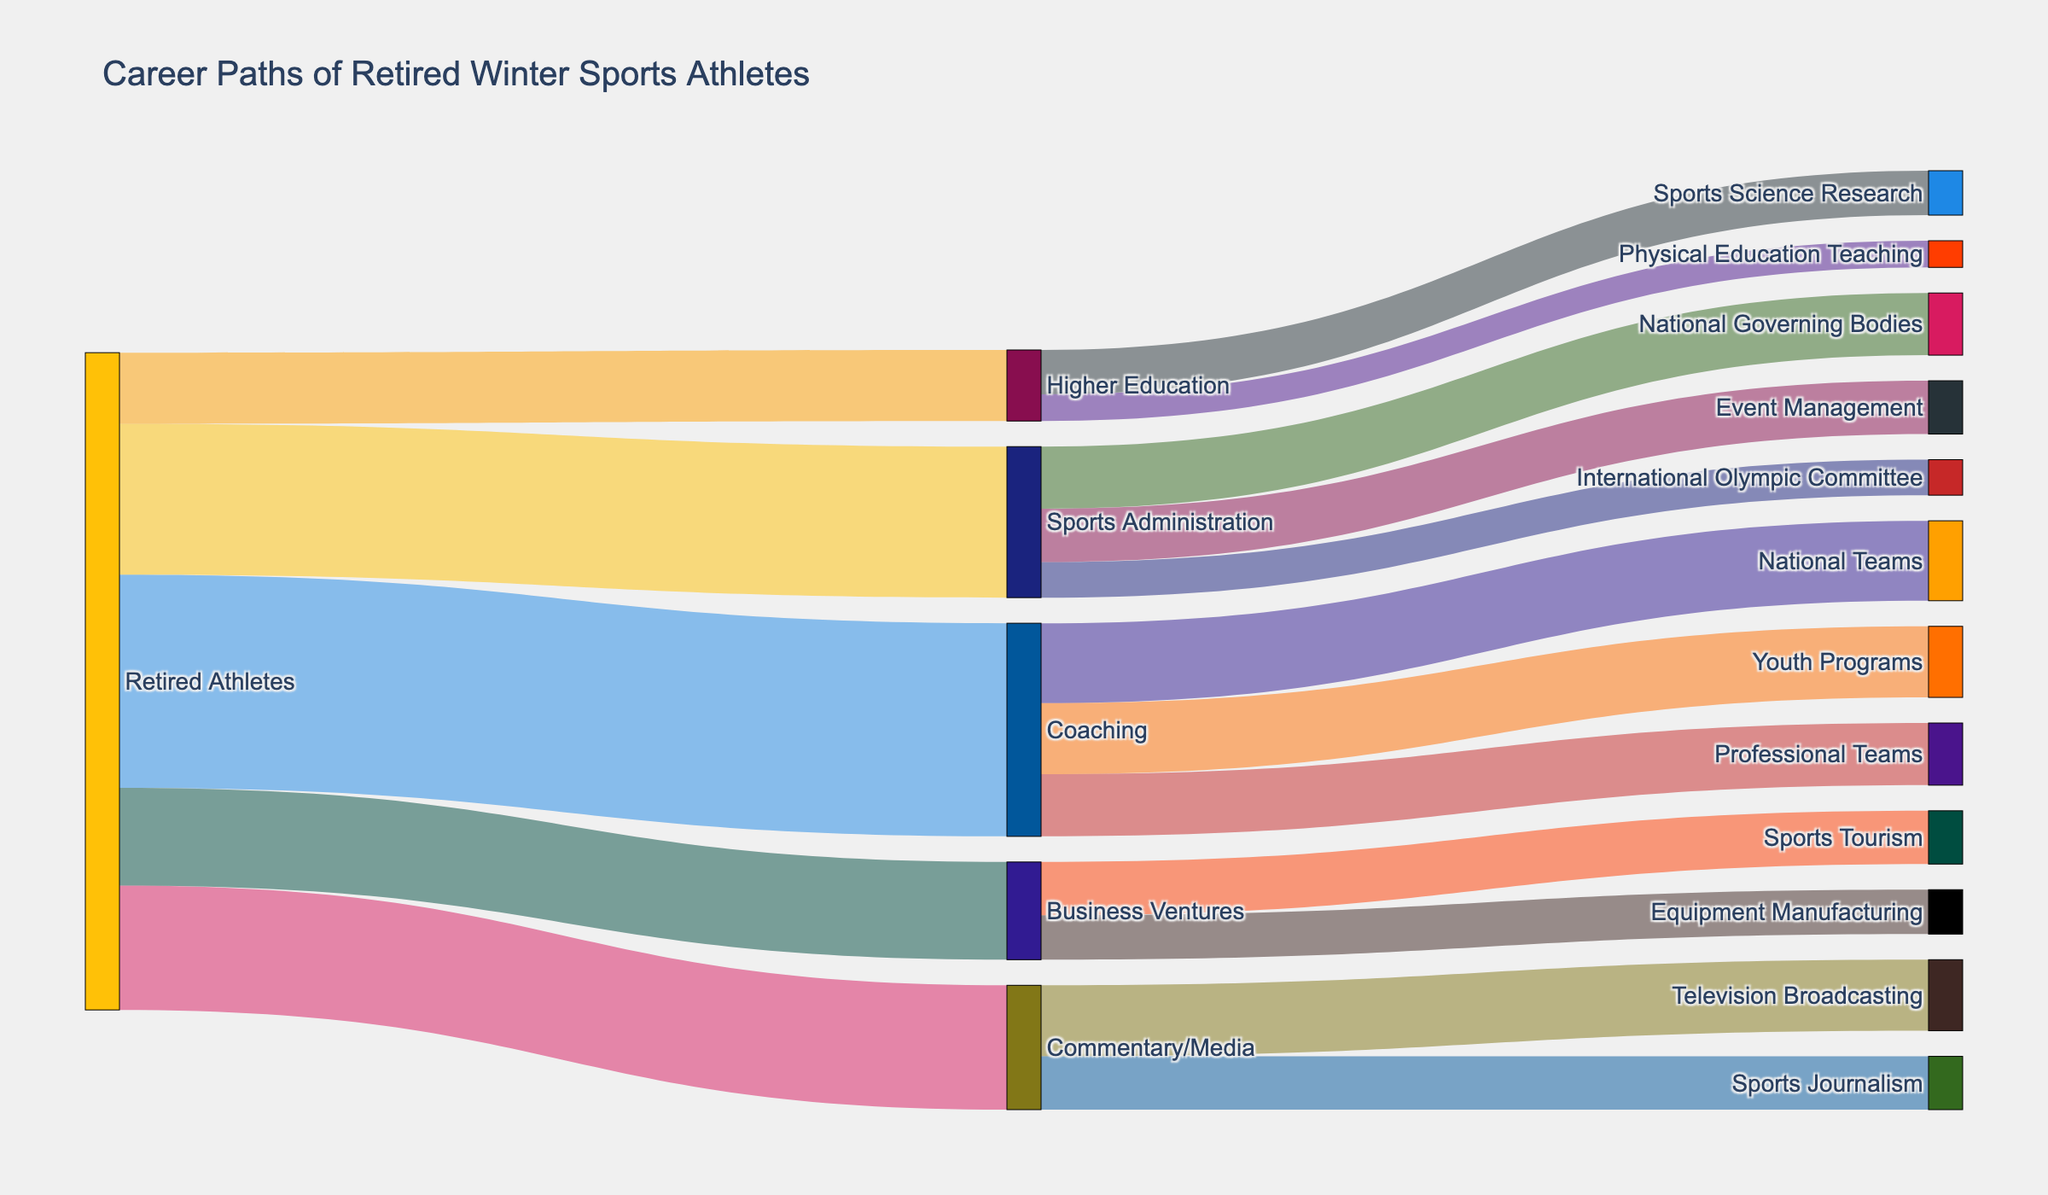What is the title of the Sankey diagram? The title is usually found at the top of the figure. In this case, it specifies the theme or subject of the diagram.
Answer: "Career Paths of Retired Winter Sports Athletes" What is the total number of retired athletes depicted in the diagram? To find the total number, sum the values of all the outgoing flows from the "Retired Athletes" node: 120 (Coaching) + 85 (Sports Administration) + 70 (Commentary/Media) + 55 (Business Ventures) + 40 (Higher Education).
Answer: 370 Which career path has the highest number of retired athletes transitioning into it? The lengths of the flows leaving the "Retired Athletes" node represent the number of athletes; compare the values: Coaching (120), Sports Administration (85), Commentary/Media (70), Business Ventures (55), Higher Education (40).
Answer: Coaching Out of those who transitioned into coaching, which specific coaching path did most athletes follow? Observe the sub-flows branching from the "Coaching" node and compare the values: National Teams (45), Professional Teams (35), Youth Programs (40).
Answer: National Teams How many retired athletes went into either Business Ventures or Higher Education combined? Sum the values of the flows into "Business Ventures" and "Higher Education": 55 (Business Ventures) + 40 (Higher Education).
Answer: 95 What proportion of athletes transitioned into Sports Administration? Calculate the fraction of athletes going into Sports Administration over the total number of retired athletes and convert to a percentage: (85 / 370) × 100%.
Answer: 22.97% Which field within Commentary/Media has the fewer retired athletes? Compare the values of the sub-flows from the "Commentary/Media" node: Television Broadcasting (40) vs. Sports Journalism (30).
Answer: Sports Journalism Which field among the higher education paths attracted the most retired athletes? Look at the flows branching from "Higher Education" and compare their values: Sports Science Research (25) vs. Physical Education Teaching (15).
Answer: Sports Science Research How many more athletes went into Youth Programs compared to Professional Teams under the Coaching path? Find the difference between the values of Youth Programs (40) and Professional Teams (35).
Answer: 5 Is Equipment Manufacturing more popular or less popular compared to Sports Tourism among those in Business Ventures? Compare the values for Equipment Manufacturing (25) and Sports Tourism (30).
Answer: Less popular 